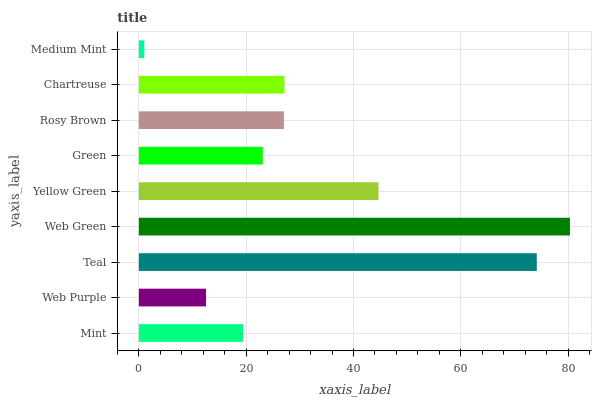Is Medium Mint the minimum?
Answer yes or no. Yes. Is Web Green the maximum?
Answer yes or no. Yes. Is Web Purple the minimum?
Answer yes or no. No. Is Web Purple the maximum?
Answer yes or no. No. Is Mint greater than Web Purple?
Answer yes or no. Yes. Is Web Purple less than Mint?
Answer yes or no. Yes. Is Web Purple greater than Mint?
Answer yes or no. No. Is Mint less than Web Purple?
Answer yes or no. No. Is Rosy Brown the high median?
Answer yes or no. Yes. Is Rosy Brown the low median?
Answer yes or no. Yes. Is Medium Mint the high median?
Answer yes or no. No. Is Green the low median?
Answer yes or no. No. 